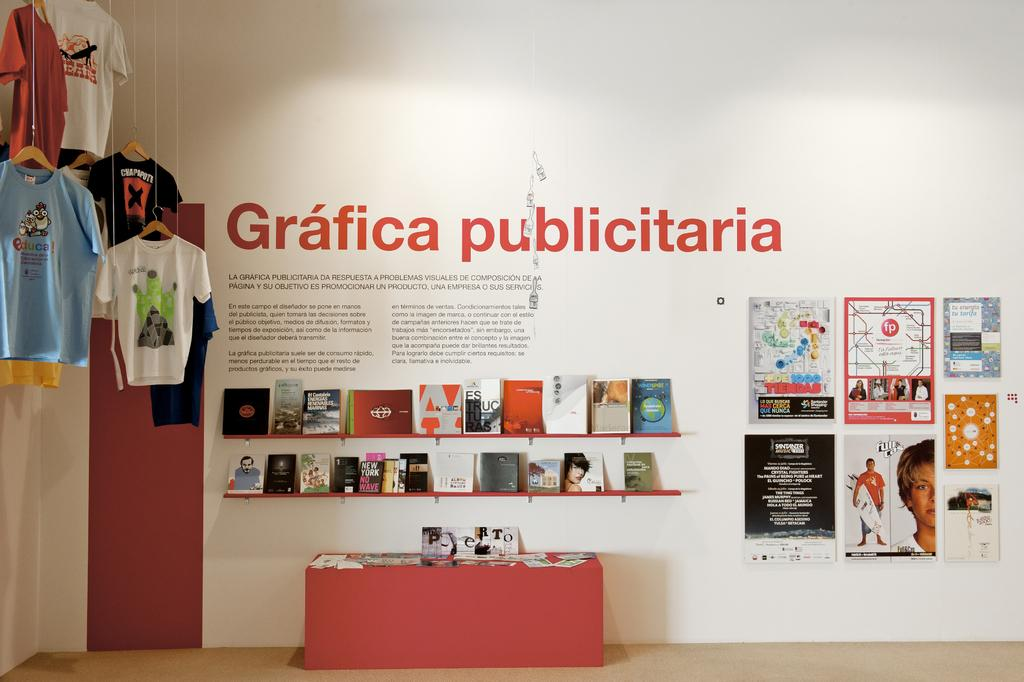<image>
Create a compact narrative representing the image presented. Various flyers line a wall and T-shirts hang to the side, all under a large sign for Grafica Publicitaria. 